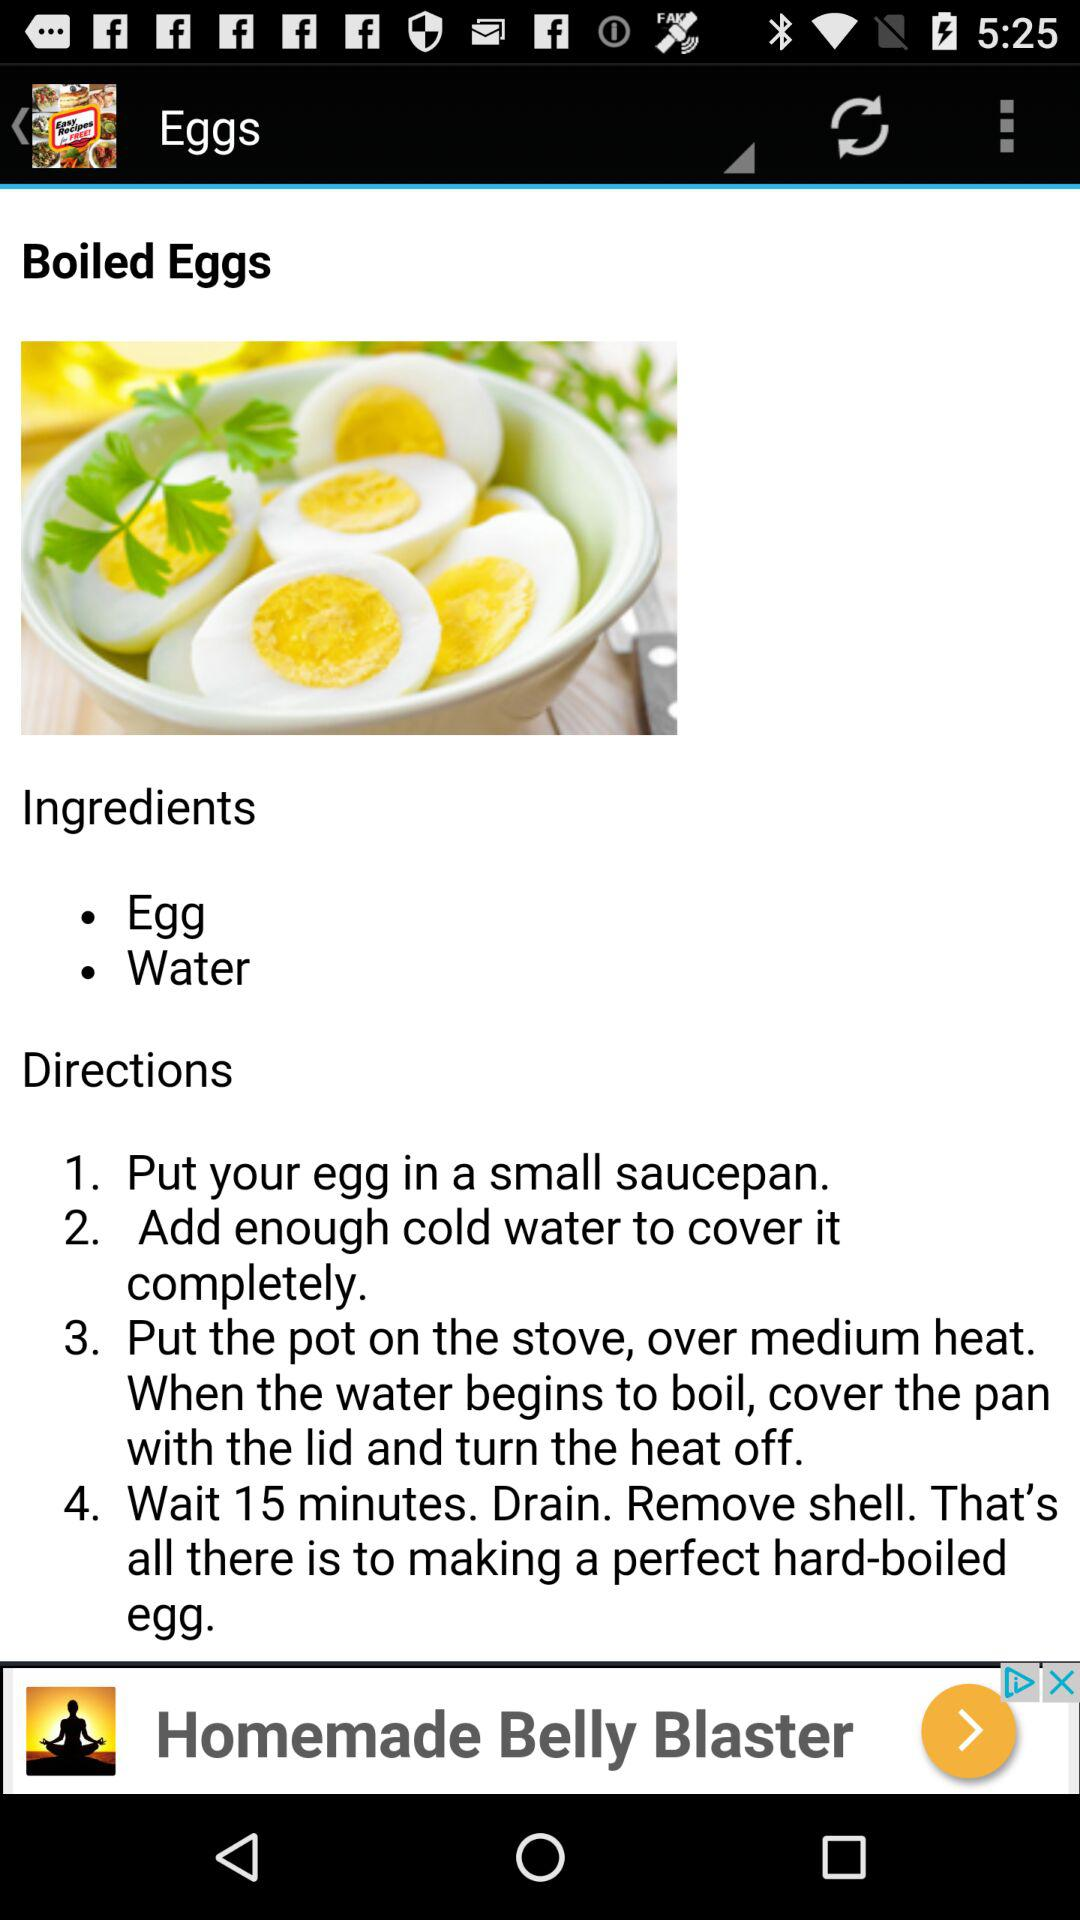How big is the egg?
When the provided information is insufficient, respond with <no answer>. <no answer> 